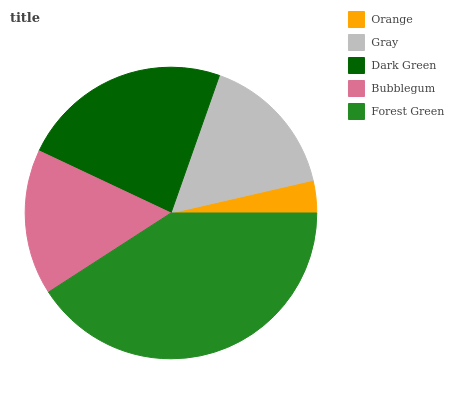Is Orange the minimum?
Answer yes or no. Yes. Is Forest Green the maximum?
Answer yes or no. Yes. Is Gray the minimum?
Answer yes or no. No. Is Gray the maximum?
Answer yes or no. No. Is Gray greater than Orange?
Answer yes or no. Yes. Is Orange less than Gray?
Answer yes or no. Yes. Is Orange greater than Gray?
Answer yes or no. No. Is Gray less than Orange?
Answer yes or no. No. Is Bubblegum the high median?
Answer yes or no. Yes. Is Bubblegum the low median?
Answer yes or no. Yes. Is Gray the high median?
Answer yes or no. No. Is Forest Green the low median?
Answer yes or no. No. 